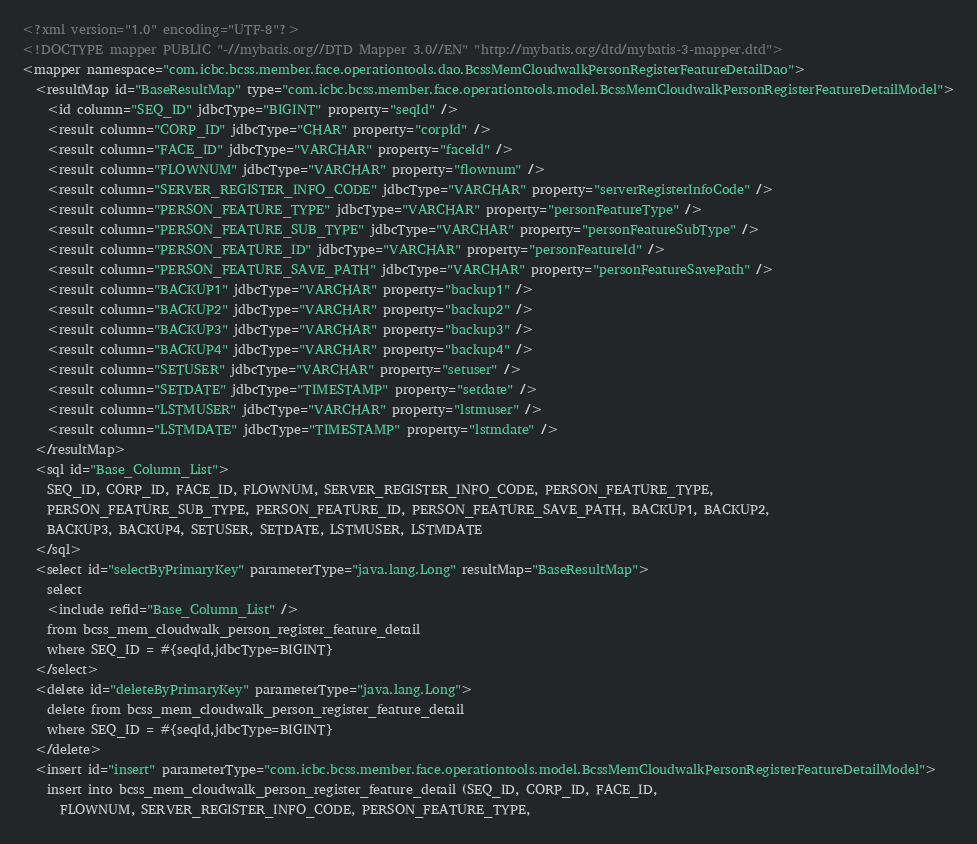<code> <loc_0><loc_0><loc_500><loc_500><_XML_><?xml version="1.0" encoding="UTF-8"?>
<!DOCTYPE mapper PUBLIC "-//mybatis.org//DTD Mapper 3.0//EN" "http://mybatis.org/dtd/mybatis-3-mapper.dtd">
<mapper namespace="com.icbc.bcss.member.face.operationtools.dao.BcssMemCloudwalkPersonRegisterFeatureDetailDao">
  <resultMap id="BaseResultMap" type="com.icbc.bcss.member.face.operationtools.model.BcssMemCloudwalkPersonRegisterFeatureDetailModel">
    <id column="SEQ_ID" jdbcType="BIGINT" property="seqId" />
    <result column="CORP_ID" jdbcType="CHAR" property="corpId" />
    <result column="FACE_ID" jdbcType="VARCHAR" property="faceId" />
    <result column="FLOWNUM" jdbcType="VARCHAR" property="flownum" />
    <result column="SERVER_REGISTER_INFO_CODE" jdbcType="VARCHAR" property="serverRegisterInfoCode" />
    <result column="PERSON_FEATURE_TYPE" jdbcType="VARCHAR" property="personFeatureType" />
    <result column="PERSON_FEATURE_SUB_TYPE" jdbcType="VARCHAR" property="personFeatureSubType" />
    <result column="PERSON_FEATURE_ID" jdbcType="VARCHAR" property="personFeatureId" />
    <result column="PERSON_FEATURE_SAVE_PATH" jdbcType="VARCHAR" property="personFeatureSavePath" />
    <result column="BACKUP1" jdbcType="VARCHAR" property="backup1" />
    <result column="BACKUP2" jdbcType="VARCHAR" property="backup2" />
    <result column="BACKUP3" jdbcType="VARCHAR" property="backup3" />
    <result column="BACKUP4" jdbcType="VARCHAR" property="backup4" />
    <result column="SETUSER" jdbcType="VARCHAR" property="setuser" />
    <result column="SETDATE" jdbcType="TIMESTAMP" property="setdate" />
    <result column="LSTMUSER" jdbcType="VARCHAR" property="lstmuser" />
    <result column="LSTMDATE" jdbcType="TIMESTAMP" property="lstmdate" />
  </resultMap>
  <sql id="Base_Column_List">
    SEQ_ID, CORP_ID, FACE_ID, FLOWNUM, SERVER_REGISTER_INFO_CODE, PERSON_FEATURE_TYPE, 
    PERSON_FEATURE_SUB_TYPE, PERSON_FEATURE_ID, PERSON_FEATURE_SAVE_PATH, BACKUP1, BACKUP2, 
    BACKUP3, BACKUP4, SETUSER, SETDATE, LSTMUSER, LSTMDATE
  </sql>
  <select id="selectByPrimaryKey" parameterType="java.lang.Long" resultMap="BaseResultMap">
    select 
    <include refid="Base_Column_List" />
    from bcss_mem_cloudwalk_person_register_feature_detail
    where SEQ_ID = #{seqId,jdbcType=BIGINT}
  </select>
  <delete id="deleteByPrimaryKey" parameterType="java.lang.Long">
    delete from bcss_mem_cloudwalk_person_register_feature_detail
    where SEQ_ID = #{seqId,jdbcType=BIGINT}
  </delete>
  <insert id="insert" parameterType="com.icbc.bcss.member.face.operationtools.model.BcssMemCloudwalkPersonRegisterFeatureDetailModel">
    insert into bcss_mem_cloudwalk_person_register_feature_detail (SEQ_ID, CORP_ID, FACE_ID, 
      FLOWNUM, SERVER_REGISTER_INFO_CODE, PERSON_FEATURE_TYPE, </code> 